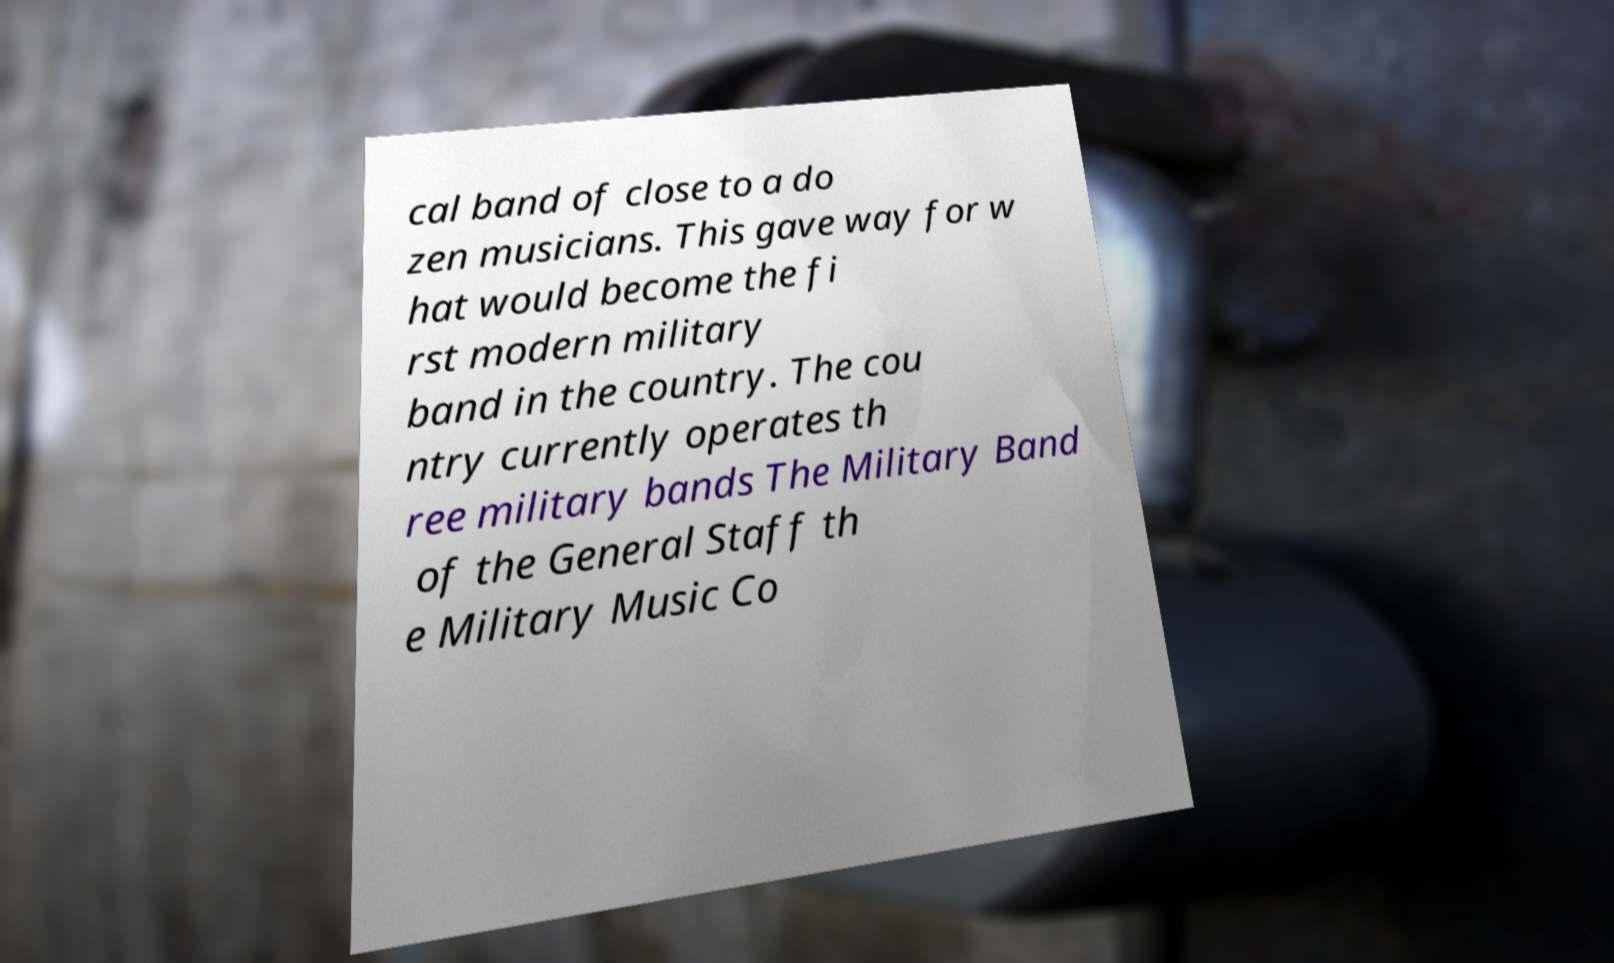I need the written content from this picture converted into text. Can you do that? cal band of close to a do zen musicians. This gave way for w hat would become the fi rst modern military band in the country. The cou ntry currently operates th ree military bands The Military Band of the General Staff th e Military Music Co 